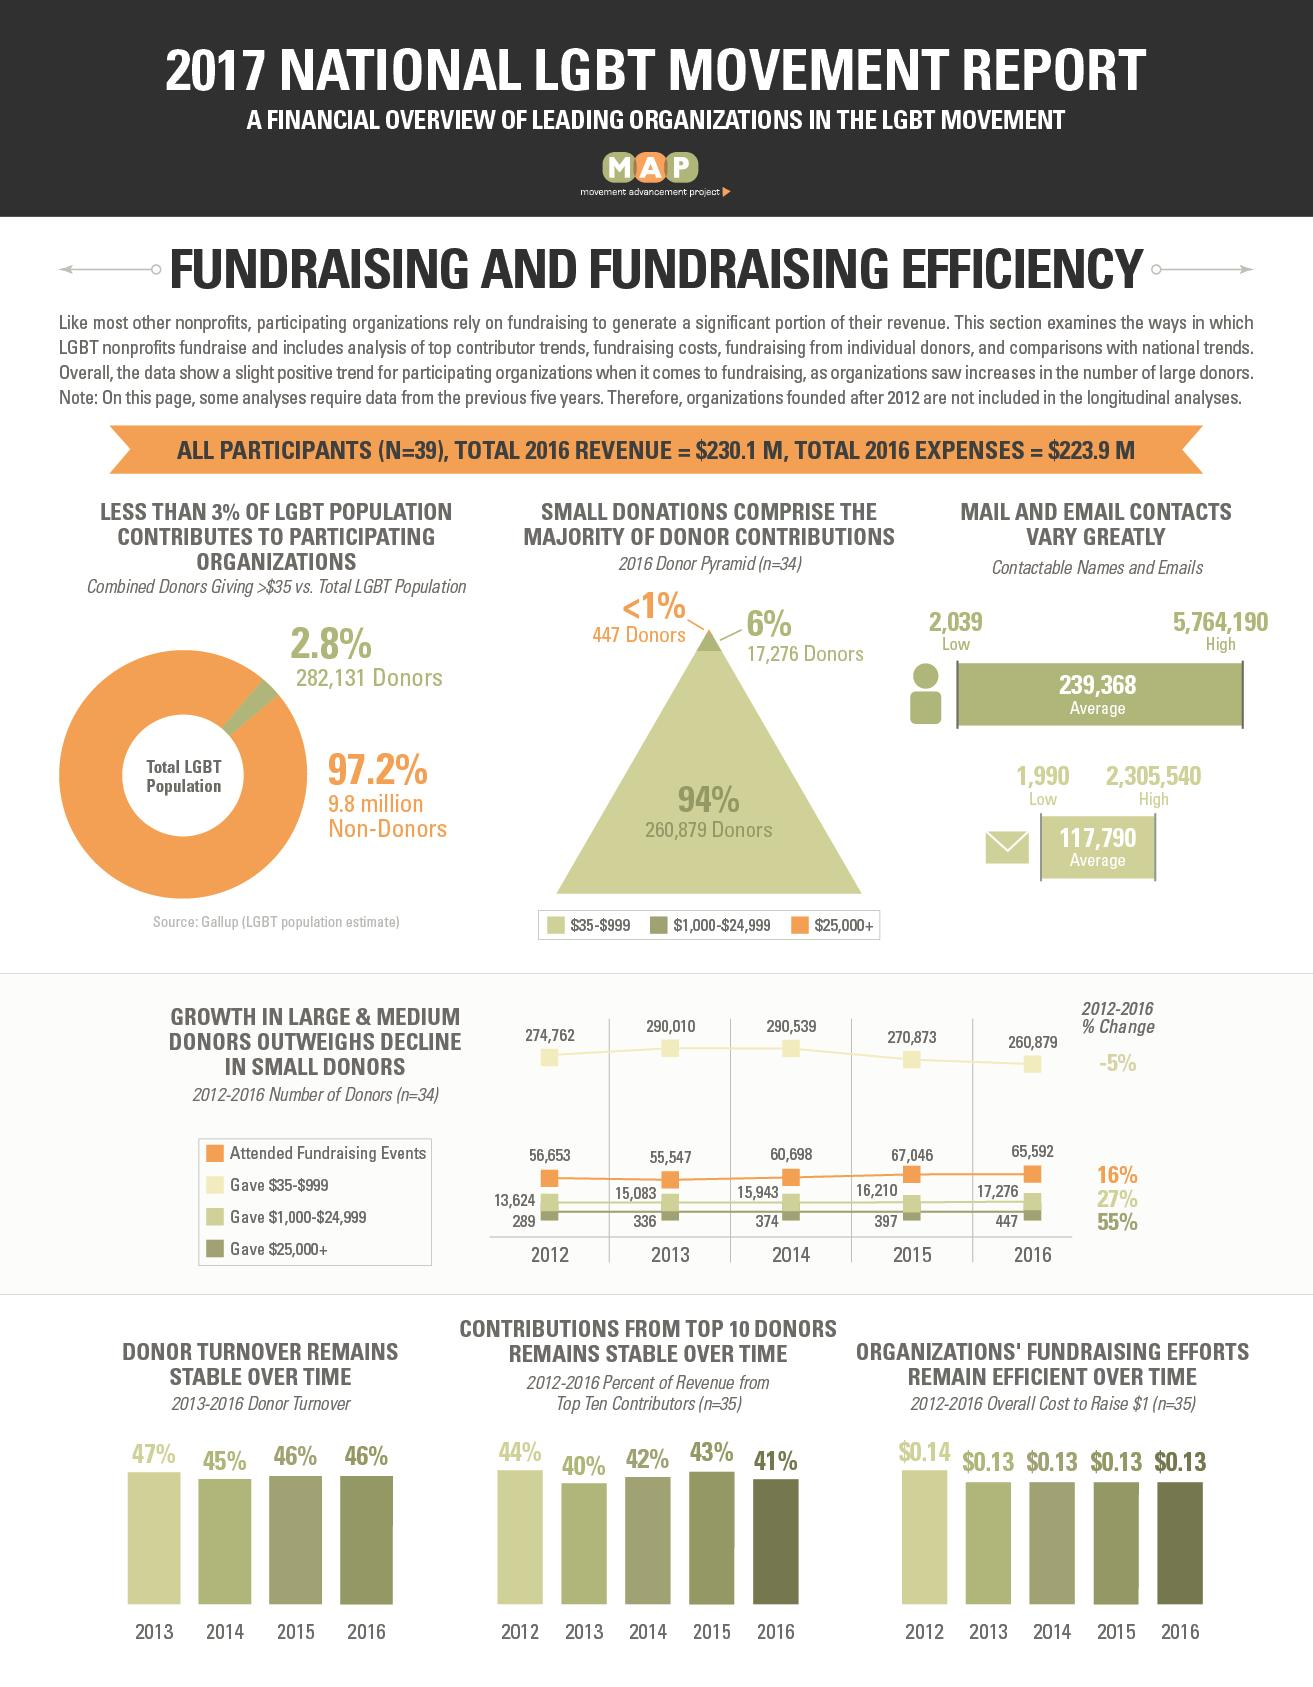Point out several critical features in this image. The pie chart shows that only 2.8% of the total LGBT population participates in participating organizations, while 97.2% do not. According to the pie chart, only 2.8% of the total LGBT population participates in participating organizations. During the period from 2012 to 2016, the number of contributors who gave more than $25,000 increased by 158 individuals. For how many years has the overall cost for fundraising remained constant? Between 2012 and 2016, there was a significant increase in the number of contributors who gave between $1,000 and $24,999. Specifically, the number of contributors in this category increased by 3652. 